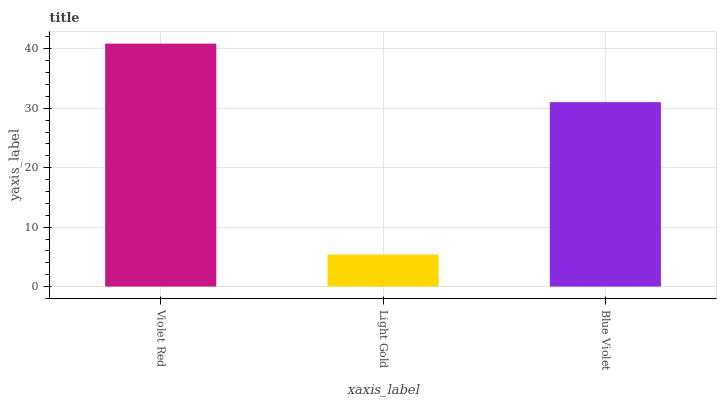Is Blue Violet the minimum?
Answer yes or no. No. Is Blue Violet the maximum?
Answer yes or no. No. Is Blue Violet greater than Light Gold?
Answer yes or no. Yes. Is Light Gold less than Blue Violet?
Answer yes or no. Yes. Is Light Gold greater than Blue Violet?
Answer yes or no. No. Is Blue Violet less than Light Gold?
Answer yes or no. No. Is Blue Violet the high median?
Answer yes or no. Yes. Is Blue Violet the low median?
Answer yes or no. Yes. Is Violet Red the high median?
Answer yes or no. No. Is Violet Red the low median?
Answer yes or no. No. 